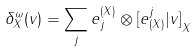Convert formula to latex. <formula><loc_0><loc_0><loc_500><loc_500>\delta ^ { \omega } _ { X } ( v ) = \sum _ { j } e _ { j } ^ { ( X ) } \otimes { [ e ^ { j } _ { ( X ) } | v ] } _ { X }</formula> 